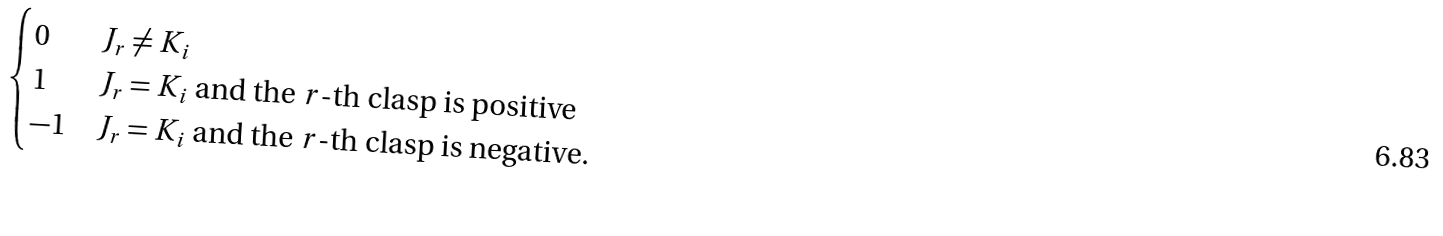Convert formula to latex. <formula><loc_0><loc_0><loc_500><loc_500>\begin{cases} 0 & J _ { r } \neq K _ { i } \\ 1 & J _ { r } = K _ { i } \text { and the } r \text {-th clasp is positive} \\ - 1 & J _ { r } = K _ { i } \text { and the } r \text {-th clasp is negative.} \end{cases}</formula> 